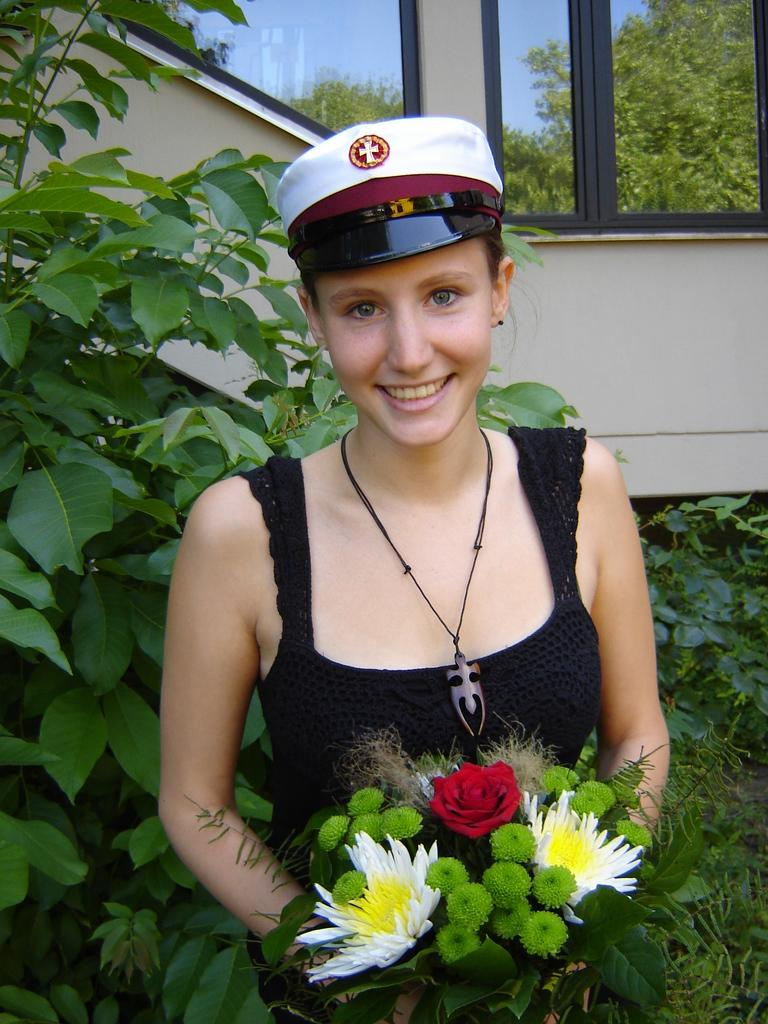Who is present in the image? There is a woman in the image. What is the woman holding in the image? The woman is holding flowers. What type of natural environment can be seen in the image? There are trees in the image. What material is visible in the image? There is glass in the image. What type of beast can be seen in the image? There is no beast present in the image. Is there a box visible in the image? There is no box present in the image. 